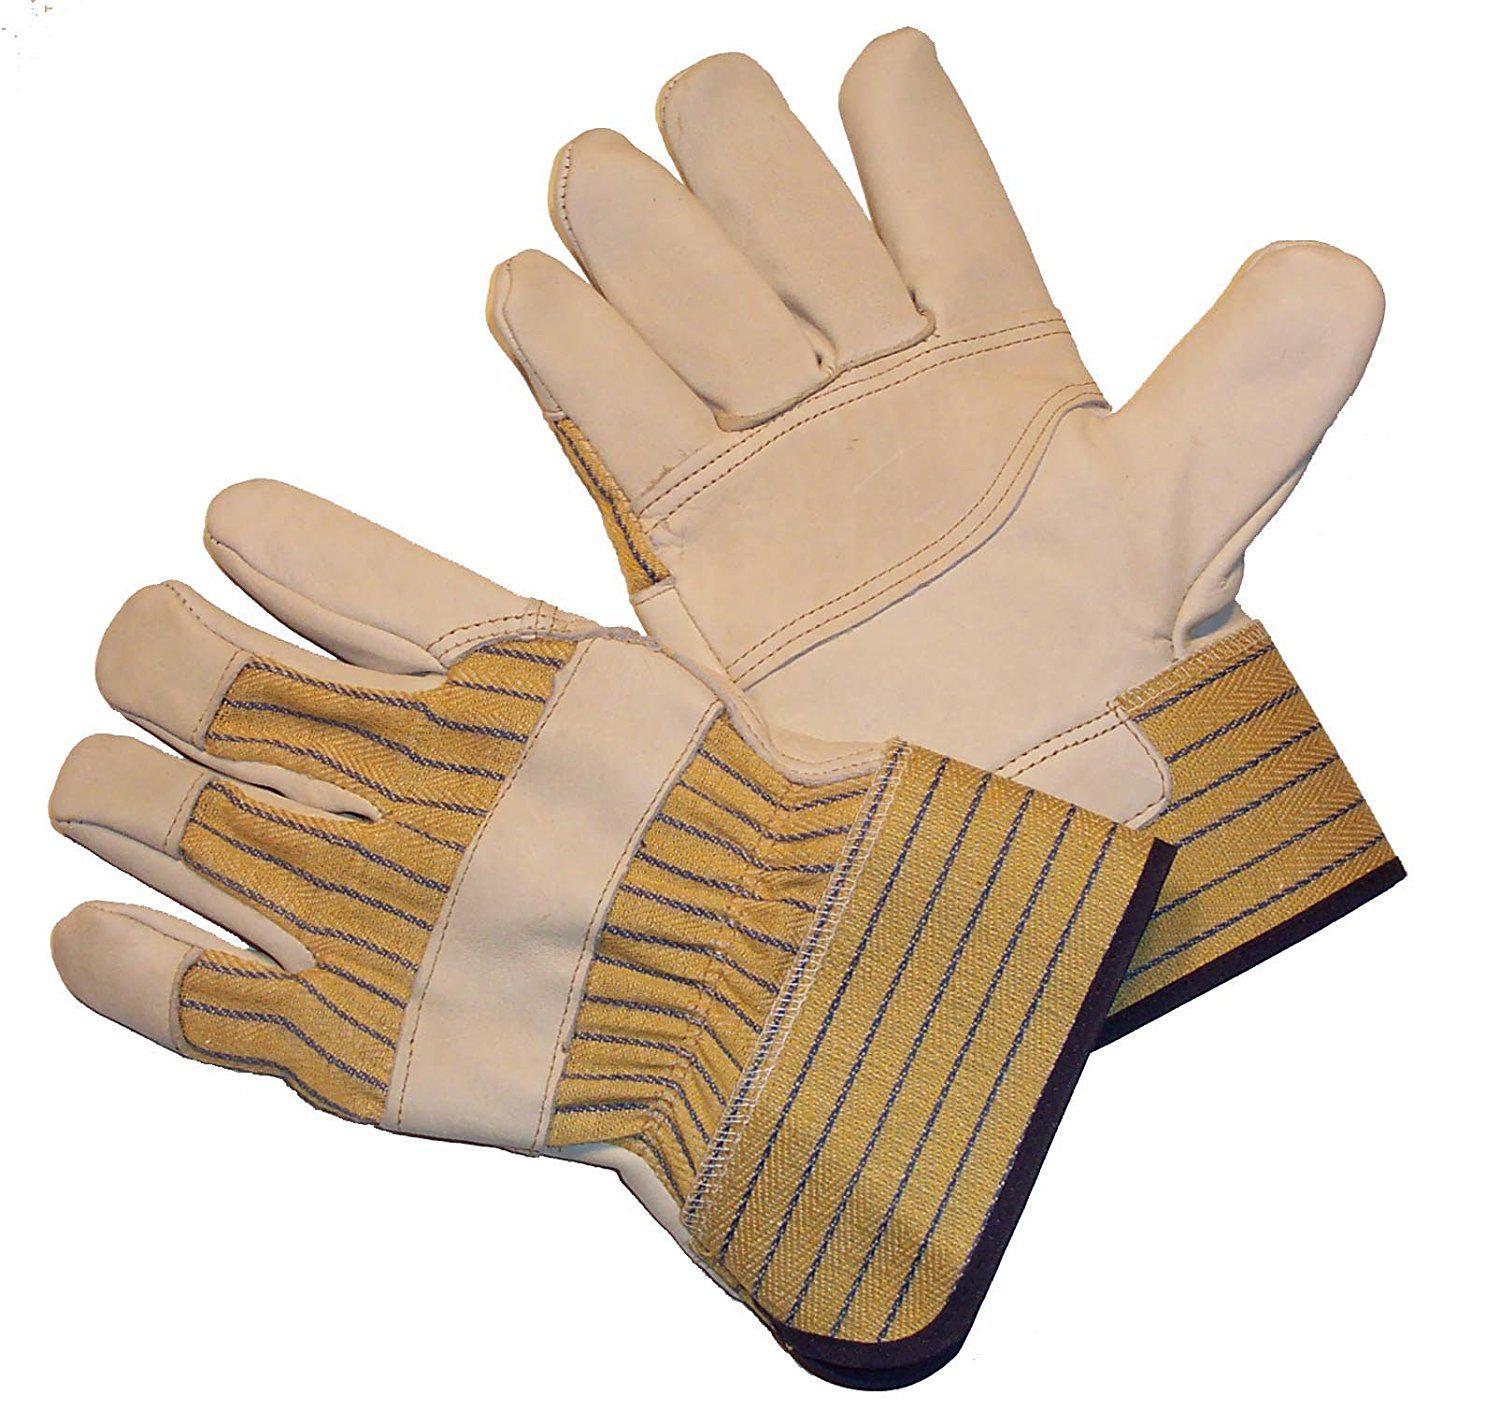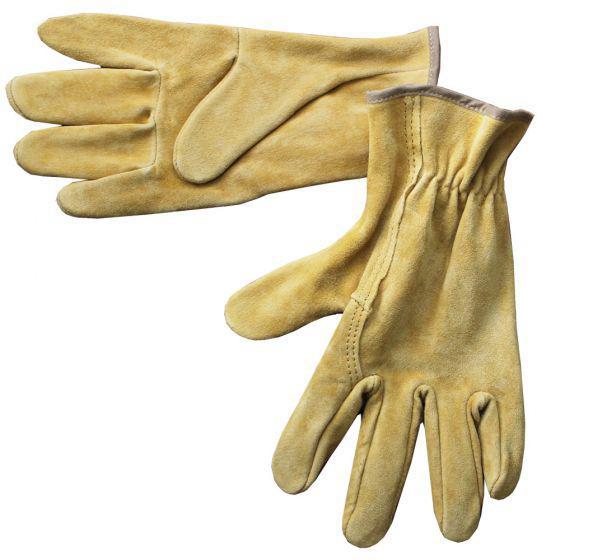The first image is the image on the left, the second image is the image on the right. Assess this claim about the two images: "The gloves all face the same direction.". Correct or not? Answer yes or no. No. The first image is the image on the left, the second image is the image on the right. Evaluate the accuracy of this statement regarding the images: "Each image shows a pair of work gloves and in one of the images the gloves are a single color.". Is it true? Answer yes or no. Yes. 